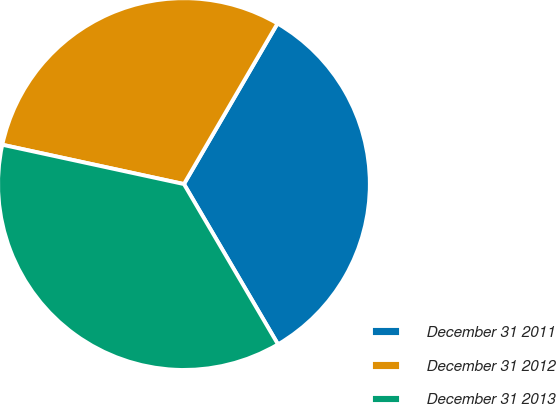Convert chart to OTSL. <chart><loc_0><loc_0><loc_500><loc_500><pie_chart><fcel>December 31 2011<fcel>December 31 2012<fcel>December 31 2013<nl><fcel>33.16%<fcel>30.0%<fcel>36.84%<nl></chart> 